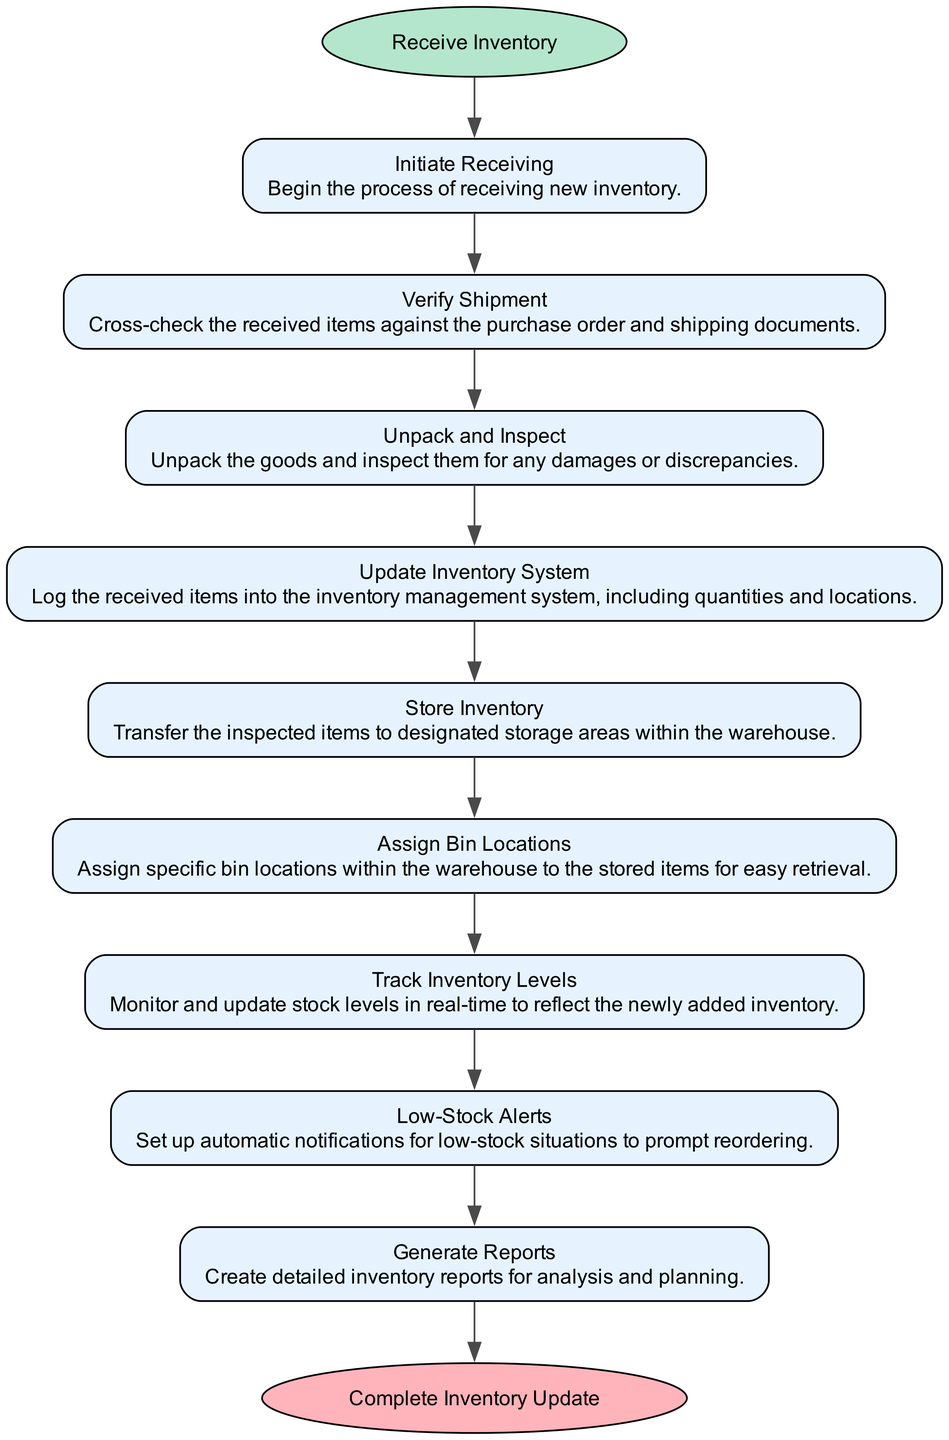What is the first step in the workflow? The first step in the workflow is labeled as "Receive Inventory." This is indicated at the start of the diagram, establishing the beginning of the process.
Answer: Receive Inventory How many steps are there in the process? By counting each of the nodes labeled from "Initiate Receiving" to "Generate Reports," I find a total of 9 steps. Each node represents a distinct activity in the inventory management workflow.
Answer: 9 What is the last step in the workflow? The last step is indicated as "Complete Inventory Update," which is the ending node in the flowchart. It signifies the conclusion of the inventory management process.
Answer: Complete Inventory Update Which step involves monitoring stock levels? The step where stock levels are monitored is labeled "Track Inventory Levels." This step captures the ongoing activity of keeping tabs on inventory quantities as they change.
Answer: Track Inventory Levels What action follows "Unpack and Inspect"? The action that follows "Unpack and Inspect" is "Update Inventory System." This indicates that after items are inspected for damages, the next step is to record these items in the inventory system.
Answer: Update Inventory System What setup occurs for low-stock situations? The setup for low-stock situations is referred to as "Low-Stock Alerts." This step is crucial for ensuring that reordering processes are triggered when stock falls below a certain threshold.
Answer: Low-Stock Alerts What is the purpose of "Generate Reports"? The purpose of "Generate Reports" is to create detailed inventory reports for analysis and planning. This step is vital for understanding inventory trends and making informed decisions.
Answer: Create detailed inventory reports How are items assigned for storage? Items are assigned for storage through the "Assign Bin Locations" step. This action organizes the inventory within the warehouse, allowing for efficient retrieval later.
Answer: Assign Bin Locations What step comes after verifying shipment? After "Verify Shipment," the next step is "Unpack and Inspect." This indicates the progression from checking the accuracy of received items to examining them physically.
Answer: Unpack and Inspect 